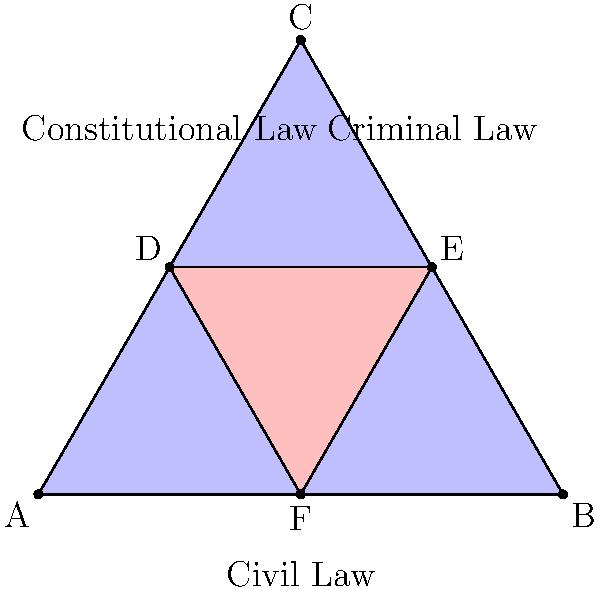In the Venn diagram representing overlapping areas of law, triangle ABC represents the entire legal system, while triangle DEF represents a specific area where Constitutional, Criminal, and Civil Law intersect. If triangle ABC has an area of 4,330 square units, what is the area of triangle DEF? Assume that triangle DEF is exactly one-fourth the size of triangle ABC. To solve this problem, we'll follow these steps:

1) First, we need to understand the relationship between the two triangles:
   - Triangle ABC represents the entire legal system
   - Triangle DEF represents the intersection of Constitutional, Criminal, and Civil Law
   - We're told that triangle DEF is exactly one-fourth the size of triangle ABC

2) We're given that the area of triangle ABC is 4,330 square units.

3) To find the area of triangle DEF, we need to calculate one-fourth of the area of triangle ABC:

   Area of DEF = $\frac{1}{4}$ × Area of ABC
   
   Area of DEF = $\frac{1}{4}$ × 4,330

4) Now, let's perform the calculation:

   Area of DEF = 4,330 ÷ 4 = 1,082.5 square units

5) Since we're dealing with area, which is typically expressed in whole units, we should round to the nearest whole number:

   Area of DEF ≈ 1,083 square units

This result shows that the area where Constitutional, Criminal, and Civil Law intersect is about 1,083 square units, which is exactly one-fourth of the entire legal system as represented in this diagram.
Answer: 1,083 square units 